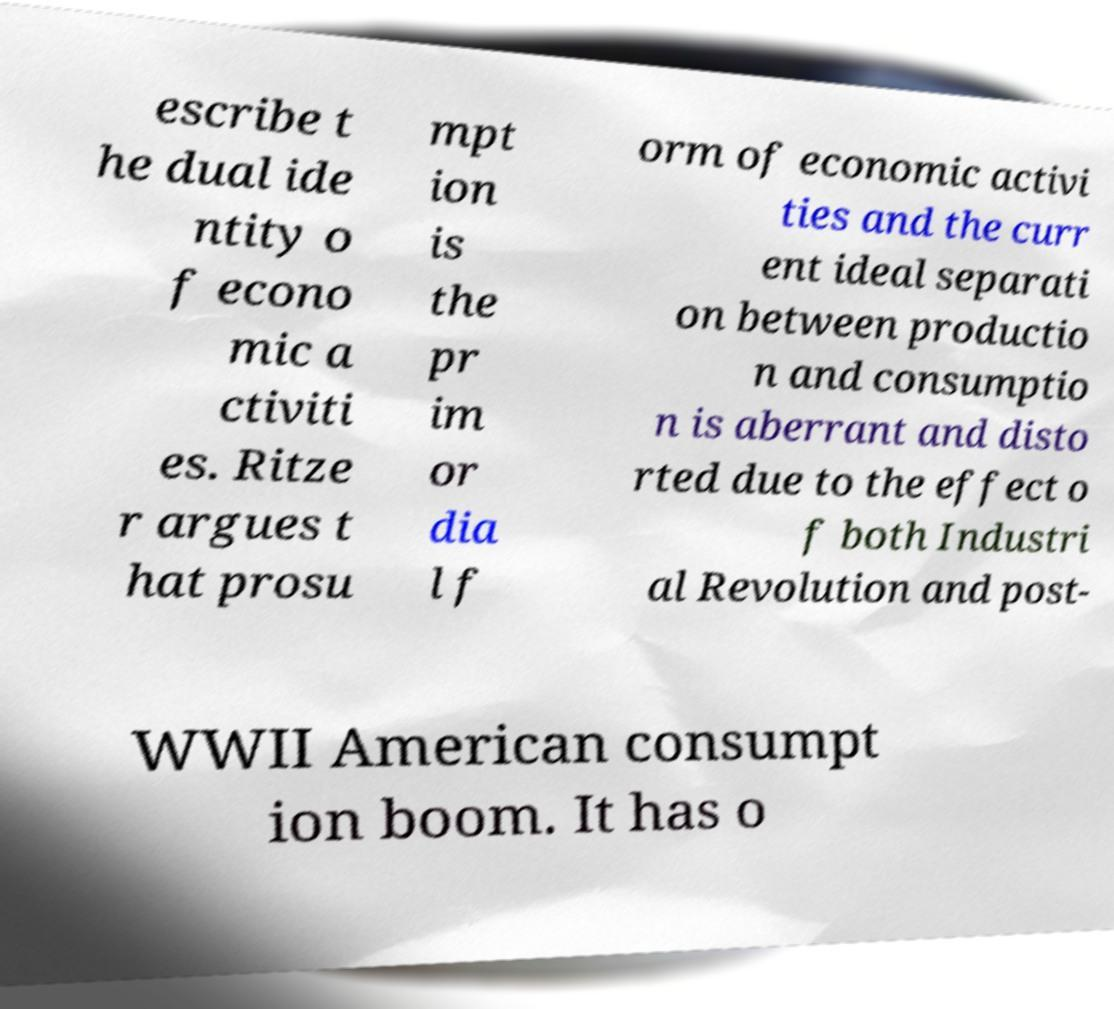Can you accurately transcribe the text from the provided image for me? escribe t he dual ide ntity o f econo mic a ctiviti es. Ritze r argues t hat prosu mpt ion is the pr im or dia l f orm of economic activi ties and the curr ent ideal separati on between productio n and consumptio n is aberrant and disto rted due to the effect o f both Industri al Revolution and post- WWII American consumpt ion boom. It has o 